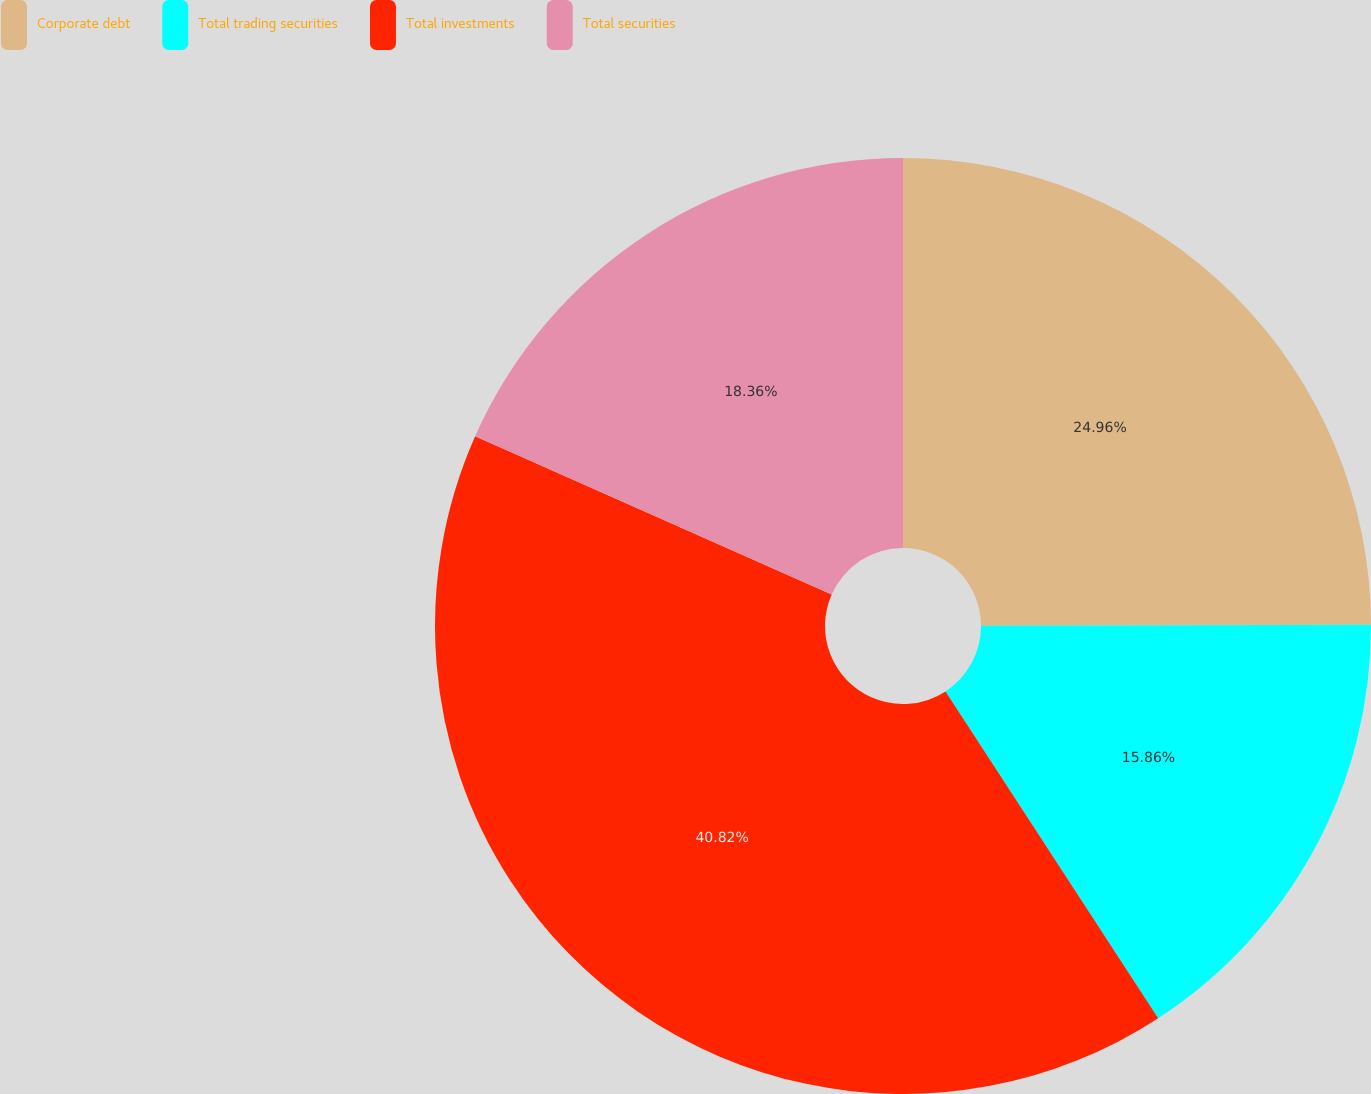Convert chart. <chart><loc_0><loc_0><loc_500><loc_500><pie_chart><fcel>Corporate debt<fcel>Total trading securities<fcel>Total investments<fcel>Total securities<nl><fcel>24.96%<fcel>15.86%<fcel>40.82%<fcel>18.36%<nl></chart> 